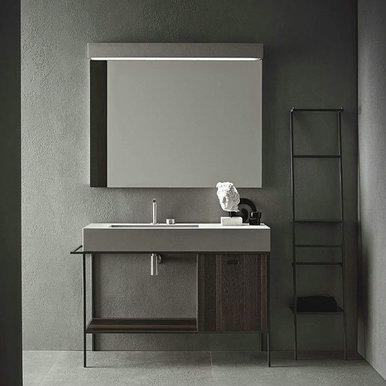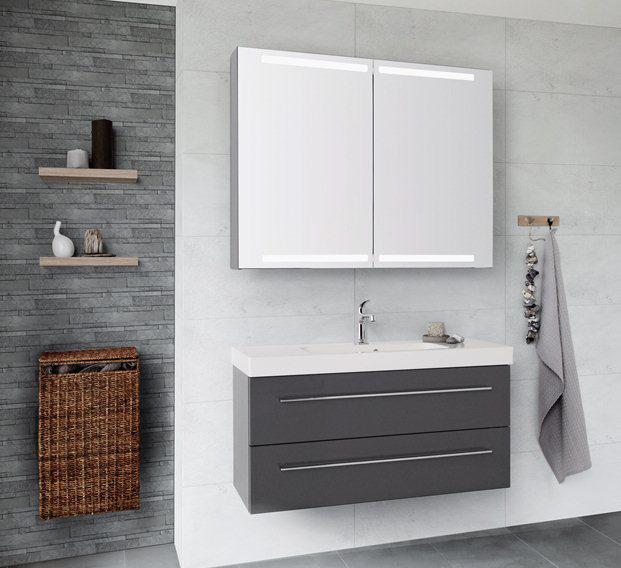The first image is the image on the left, the second image is the image on the right. Assess this claim about the two images: "The bowl of the sink in the image on the right is oval.". Correct or not? Answer yes or no. No. The first image is the image on the left, the second image is the image on the right. For the images shown, is this caption "One of the sinks is inset in a rectangle above metal legs." true? Answer yes or no. Yes. 